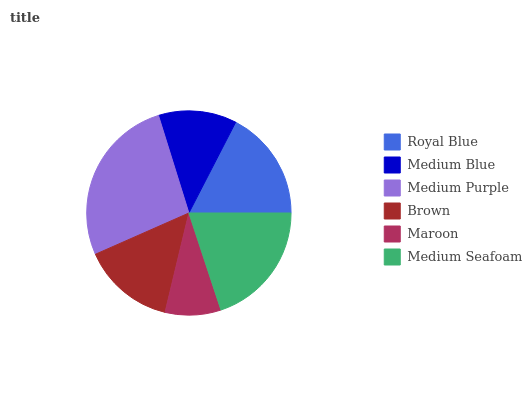Is Maroon the minimum?
Answer yes or no. Yes. Is Medium Purple the maximum?
Answer yes or no. Yes. Is Medium Blue the minimum?
Answer yes or no. No. Is Medium Blue the maximum?
Answer yes or no. No. Is Royal Blue greater than Medium Blue?
Answer yes or no. Yes. Is Medium Blue less than Royal Blue?
Answer yes or no. Yes. Is Medium Blue greater than Royal Blue?
Answer yes or no. No. Is Royal Blue less than Medium Blue?
Answer yes or no. No. Is Royal Blue the high median?
Answer yes or no. Yes. Is Brown the low median?
Answer yes or no. Yes. Is Maroon the high median?
Answer yes or no. No. Is Medium Seafoam the low median?
Answer yes or no. No. 